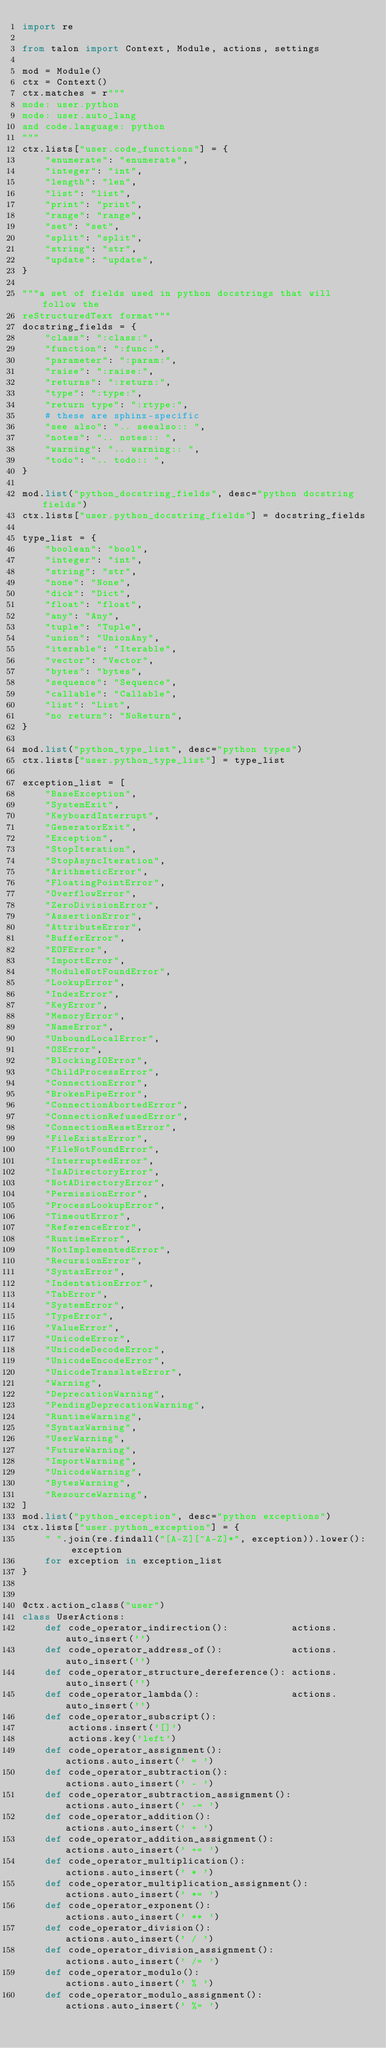Convert code to text. <code><loc_0><loc_0><loc_500><loc_500><_Python_>import re

from talon import Context, Module, actions, settings

mod = Module()
ctx = Context()
ctx.matches = r"""
mode: user.python
mode: user.auto_lang
and code.language: python
"""
ctx.lists["user.code_functions"] = {
    "enumerate": "enumerate",
    "integer": "int",
    "length": "len",
    "list": "list",
    "print": "print",
    "range": "range",
    "set": "set",
    "split": "split",
    "string": "str",
    "update": "update",
}

"""a set of fields used in python docstrings that will follow the
reStructuredText format"""
docstring_fields = {
    "class": ":class:",
    "function": ":func:",
    "parameter": ":param:",
    "raise": ":raise:",
    "returns": ":return:",
    "type": ":type:",
    "return type": ":rtype:",
    # these are sphinx-specific
    "see also": ".. seealso:: ",
    "notes": ".. notes:: ",
    "warning": ".. warning:: ",
    "todo": ".. todo:: ",
}

mod.list("python_docstring_fields", desc="python docstring fields")
ctx.lists["user.python_docstring_fields"] = docstring_fields

type_list = {
    "boolean": "bool",
    "integer": "int",
    "string": "str",
    "none": "None",
    "dick": "Dict",
    "float": "float",
    "any": "Any",
    "tuple": "Tuple",
    "union": "UnionAny",
    "iterable": "Iterable",
    "vector": "Vector",
    "bytes": "bytes",
    "sequence": "Sequence",
    "callable": "Callable",
    "list": "List",
    "no return": "NoReturn",
}

mod.list("python_type_list", desc="python types")
ctx.lists["user.python_type_list"] = type_list

exception_list = [
    "BaseException",
    "SystemExit",
    "KeyboardInterrupt",
    "GeneratorExit",
    "Exception",
    "StopIteration",
    "StopAsyncIteration",
    "ArithmeticError",
    "FloatingPointError",
    "OverflowError",
    "ZeroDivisionError",
    "AssertionError",
    "AttributeError",
    "BufferError",
    "EOFError",
    "ImportError",
    "ModuleNotFoundError",
    "LookupError",
    "IndexError",
    "KeyError",
    "MemoryError",
    "NameError",
    "UnboundLocalError",
    "OSError",
    "BlockingIOError",
    "ChildProcessError",
    "ConnectionError",
    "BrokenPipeError",
    "ConnectionAbortedError",
    "ConnectionRefusedError",
    "ConnectionResetError",
    "FileExistsError",
    "FileNotFoundError",
    "InterruptedError",
    "IsADirectoryError",
    "NotADirectoryError",
    "PermissionError",
    "ProcessLookupError",
    "TimeoutError",
    "ReferenceError",
    "RuntimeError",
    "NotImplementedError",
    "RecursionError",
    "SyntaxError",
    "IndentationError",
    "TabError",
    "SystemError",
    "TypeError",
    "ValueError",
    "UnicodeError",
    "UnicodeDecodeError",
    "UnicodeEncodeError",
    "UnicodeTranslateError",
    "Warning",
    "DeprecationWarning",
    "PendingDeprecationWarning",
    "RuntimeWarning",
    "SyntaxWarning",
    "UserWarning",
    "FutureWarning",
    "ImportWarning",
    "UnicodeWarning",
    "BytesWarning",
    "ResourceWarning",
]
mod.list("python_exception", desc="python exceptions")
ctx.lists["user.python_exception"] = {
    " ".join(re.findall("[A-Z][^A-Z]*", exception)).lower(): exception
    for exception in exception_list
}


@ctx.action_class("user")
class UserActions:
    def code_operator_indirection():           actions.auto_insert('')
    def code_operator_address_of():            actions.auto_insert('')
    def code_operator_structure_dereference(): actions.auto_insert('')
    def code_operator_lambda():                actions.auto_insert('')
    def code_operator_subscript():
        actions.insert('[]')
        actions.key('left')
    def code_operator_assignment():                      actions.auto_insert(' = ')
    def code_operator_subtraction():                     actions.auto_insert(' - ')
    def code_operator_subtraction_assignment():          actions.auto_insert(' -= ')
    def code_operator_addition():                        actions.auto_insert(' + ')
    def code_operator_addition_assignment():             actions.auto_insert(' += ')
    def code_operator_multiplication():                  actions.auto_insert(' * ')
    def code_operator_multiplication_assignment():       actions.auto_insert(' *= ')
    def code_operator_exponent():                        actions.auto_insert(' ** ')
    def code_operator_division():                        actions.auto_insert(' / ')
    def code_operator_division_assignment():             actions.auto_insert(' /= ')
    def code_operator_modulo():                          actions.auto_insert(' % ')
    def code_operator_modulo_assignment():               actions.auto_insert(' %= ')</code> 